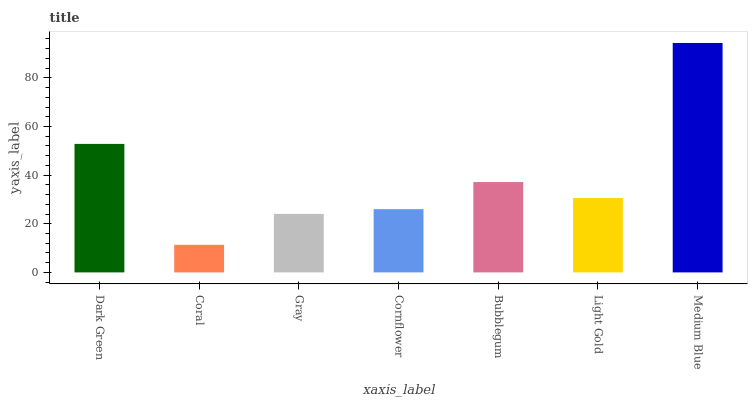Is Coral the minimum?
Answer yes or no. Yes. Is Medium Blue the maximum?
Answer yes or no. Yes. Is Gray the minimum?
Answer yes or no. No. Is Gray the maximum?
Answer yes or no. No. Is Gray greater than Coral?
Answer yes or no. Yes. Is Coral less than Gray?
Answer yes or no. Yes. Is Coral greater than Gray?
Answer yes or no. No. Is Gray less than Coral?
Answer yes or no. No. Is Light Gold the high median?
Answer yes or no. Yes. Is Light Gold the low median?
Answer yes or no. Yes. Is Coral the high median?
Answer yes or no. No. Is Medium Blue the low median?
Answer yes or no. No. 